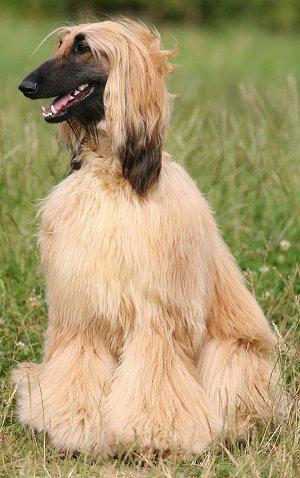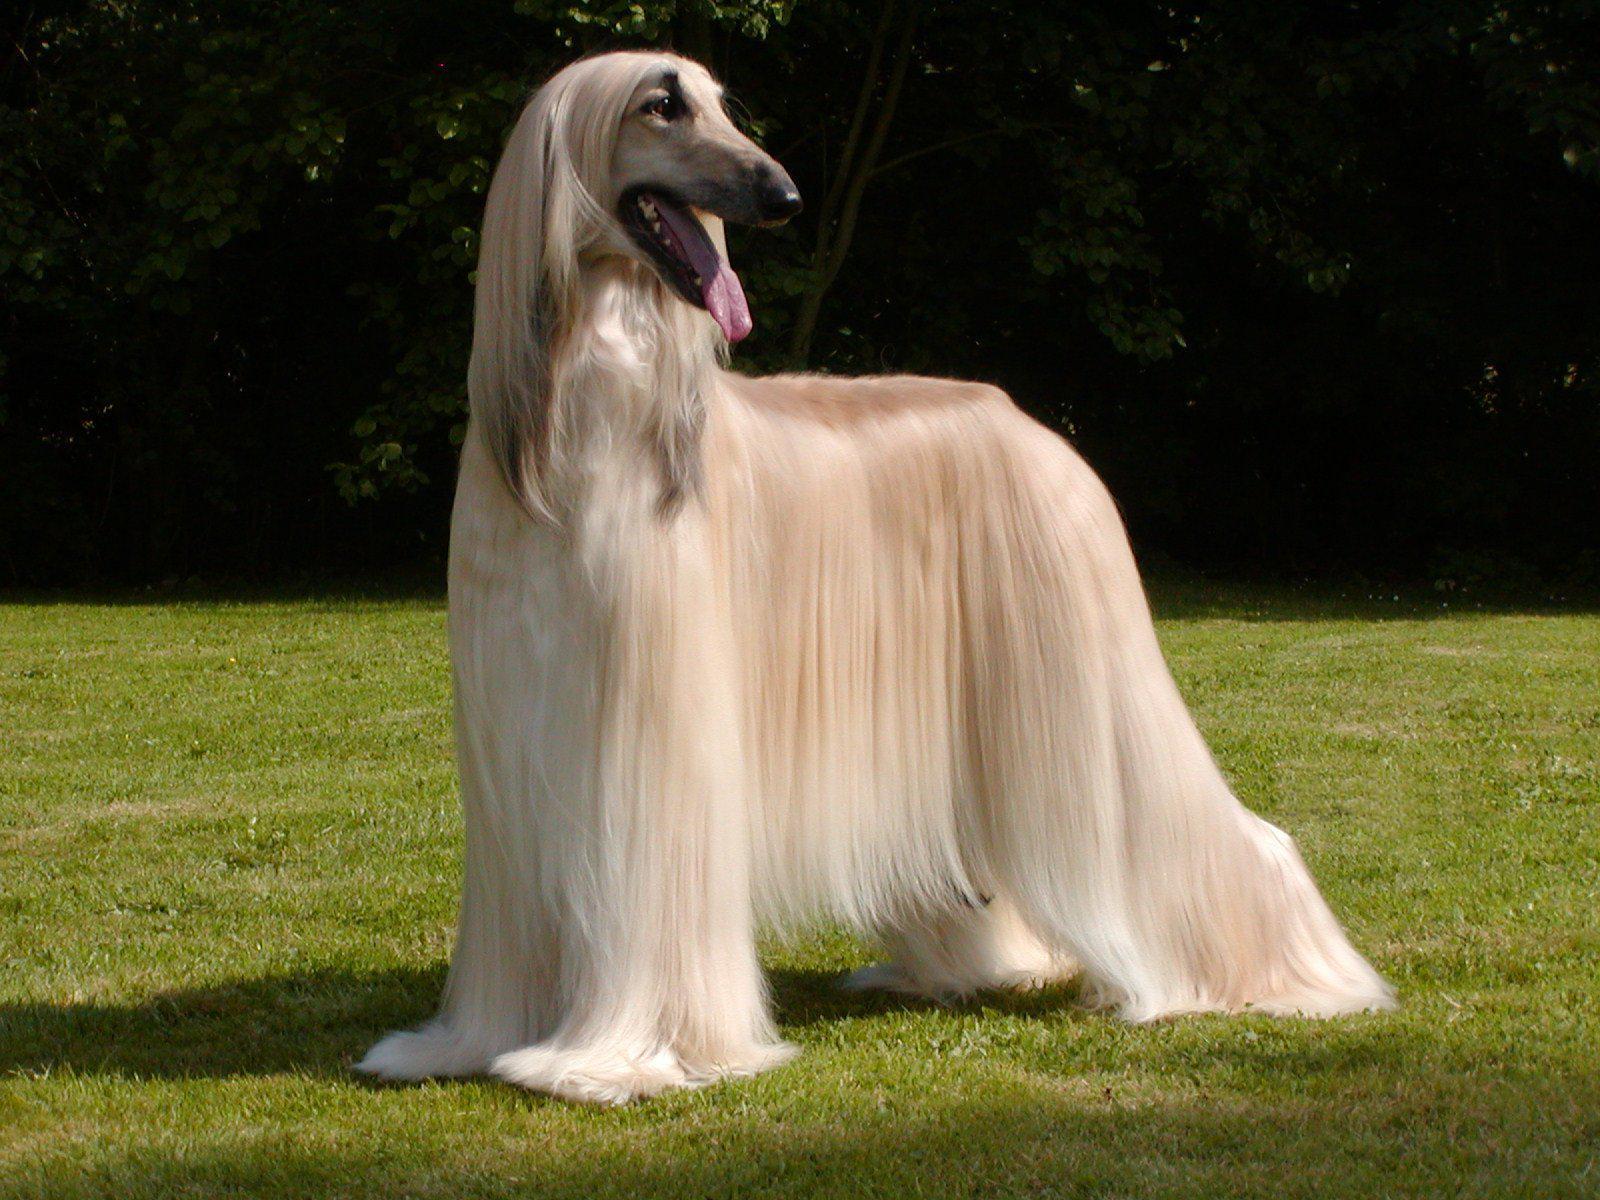The first image is the image on the left, the second image is the image on the right. Examine the images to the left and right. Is the description "At least one dog is sitting upright in the grass." accurate? Answer yes or no. Yes. 